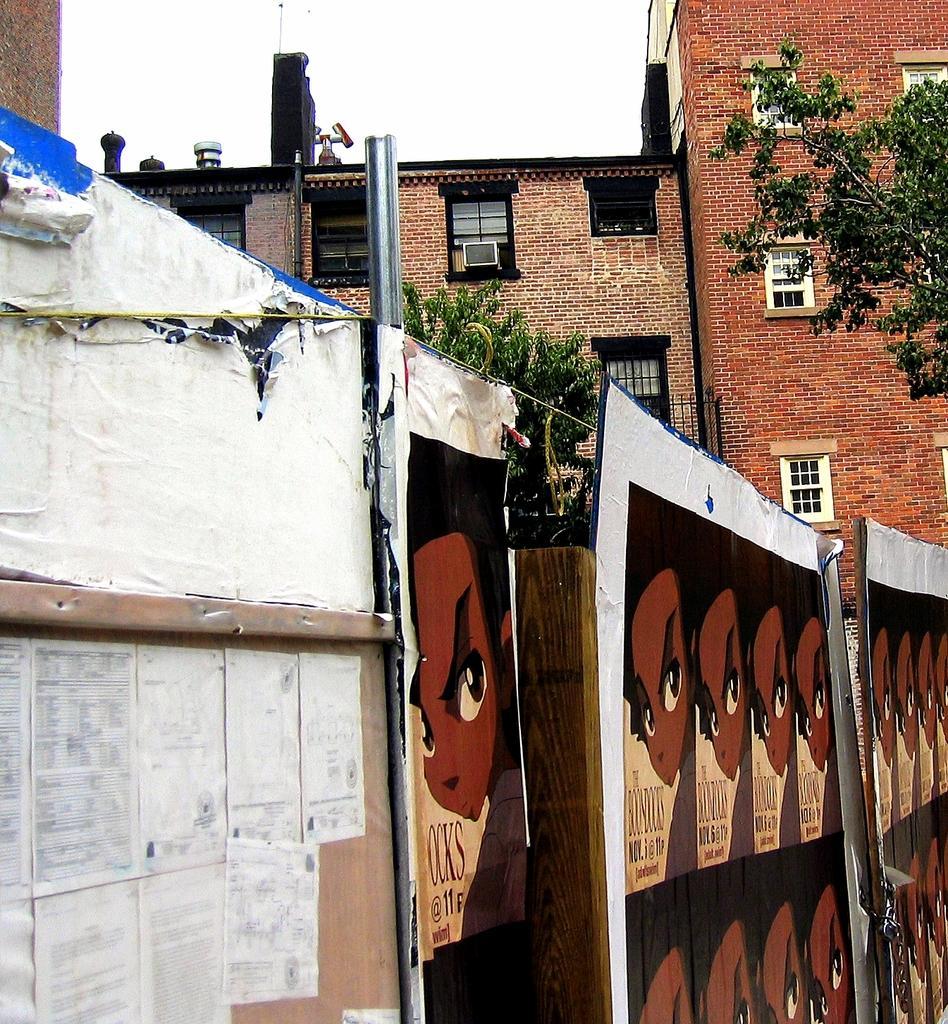Describe this image in one or two sentences. In the picture I can see a fence which has few papers and posters attached on it and there is a building and trees in the background. 